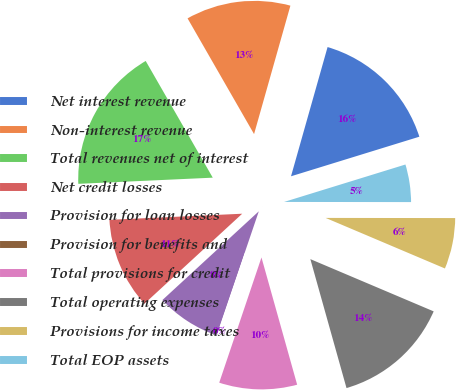Convert chart. <chart><loc_0><loc_0><loc_500><loc_500><pie_chart><fcel>Net interest revenue<fcel>Non-interest revenue<fcel>Total revenues net of interest<fcel>Net credit losses<fcel>Provision for loan losses<fcel>Provision for benefits and<fcel>Total provisions for credit<fcel>Total operating expenses<fcel>Provisions for income taxes<fcel>Total EOP assets<nl><fcel>15.85%<fcel>12.69%<fcel>17.43%<fcel>11.11%<fcel>7.94%<fcel>0.04%<fcel>9.53%<fcel>14.27%<fcel>6.36%<fcel>4.78%<nl></chart> 